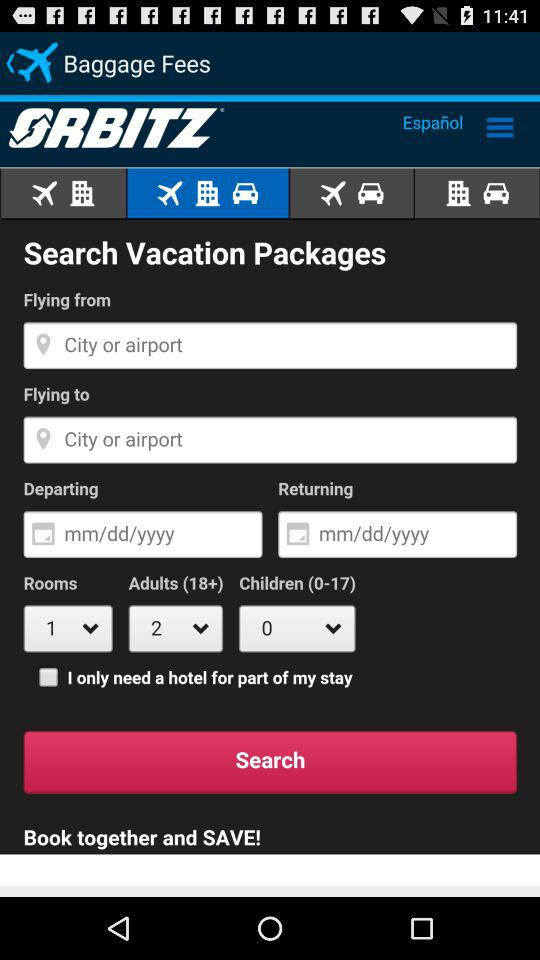How many children are selected? The selected number of children is 0. 